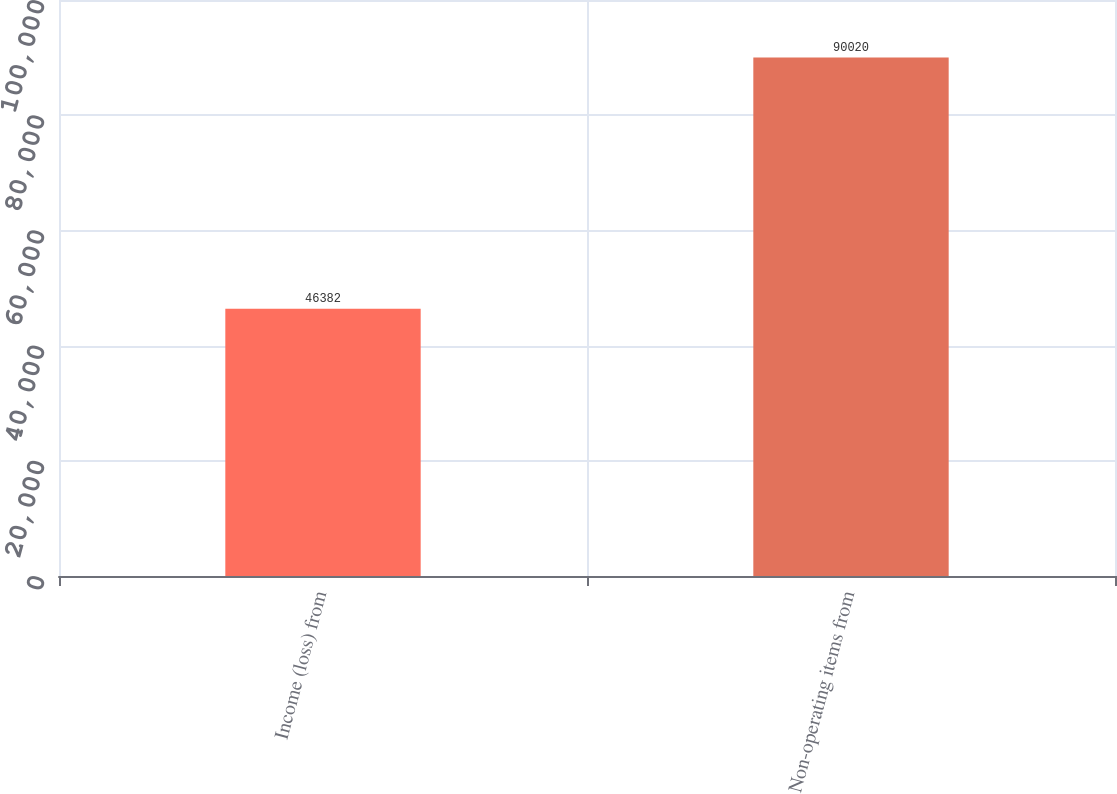Convert chart to OTSL. <chart><loc_0><loc_0><loc_500><loc_500><bar_chart><fcel>Income (loss) from<fcel>Non-operating items from<nl><fcel>46382<fcel>90020<nl></chart> 